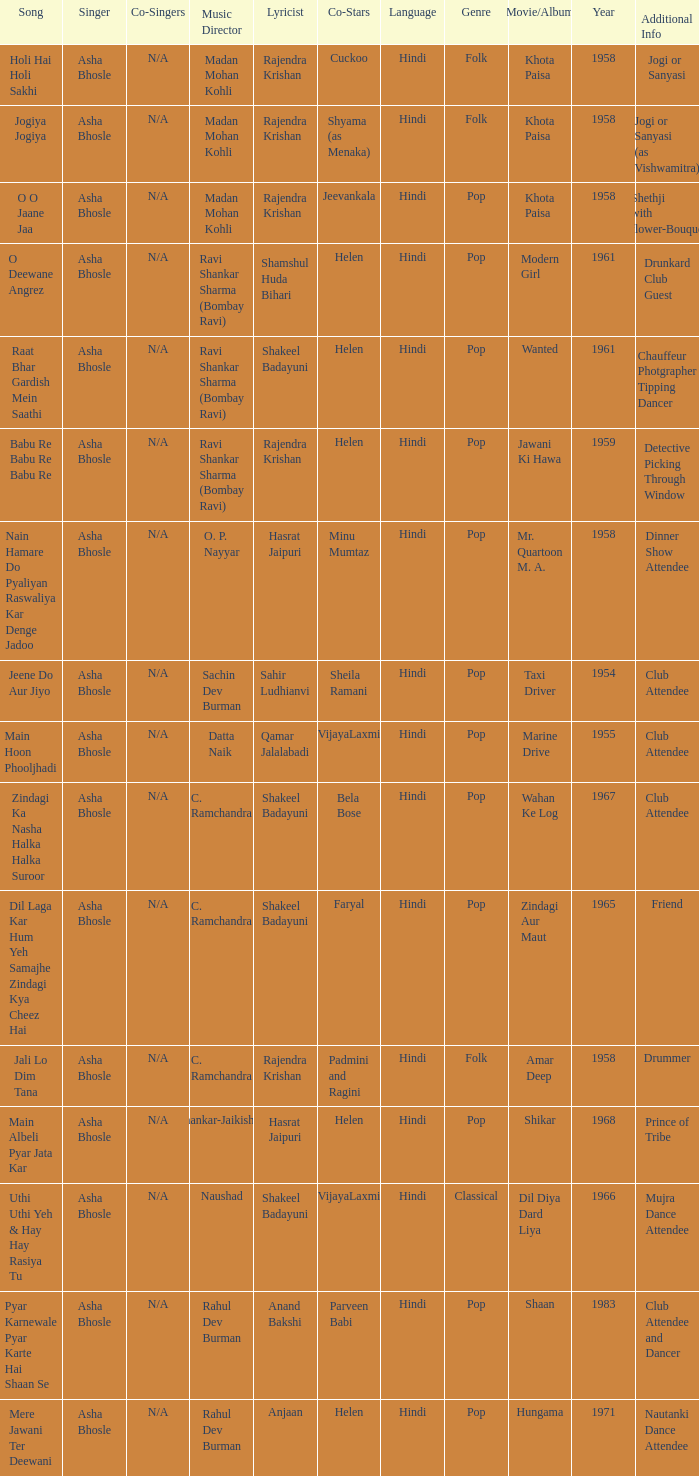Who wrote the lyrics when Jeevankala co-starred? Rajendra Krishan. 